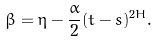Convert formula to latex. <formula><loc_0><loc_0><loc_500><loc_500>\beta = \eta - \frac { \alpha } { 2 } ( t - s ) ^ { 2 H } .</formula> 